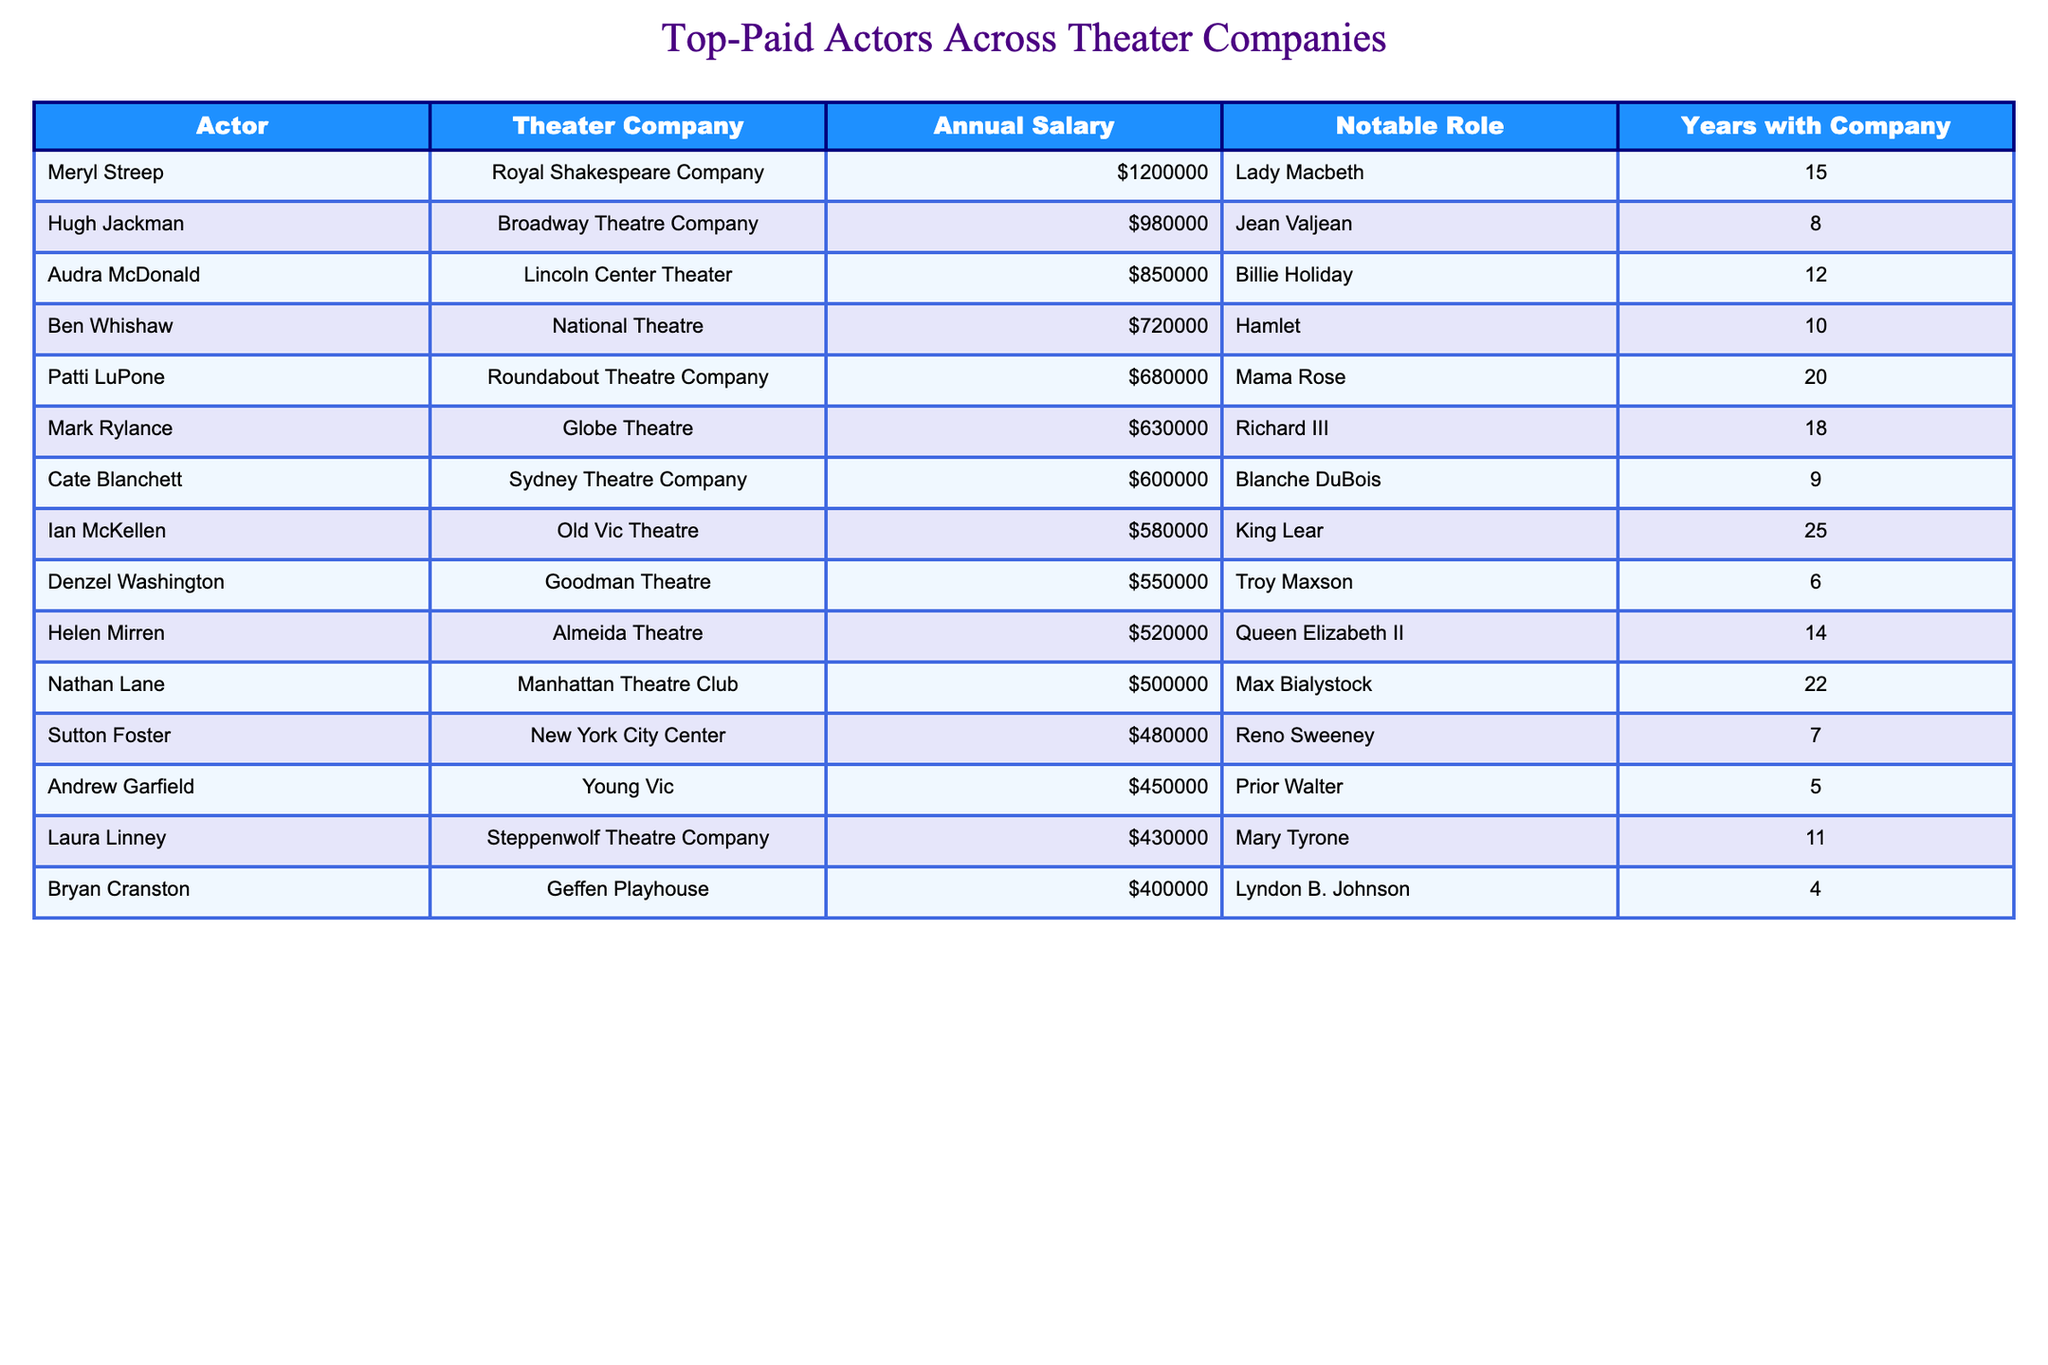What is the highest annual salary among the actors listed? Meryl Streep has the highest salary of $1,200,000. This is evident from the table where her salary is notably the largest compared to others.
Answer: $1,200,000 Which actor has been with their theater company for the longest time? Ian McKellen has been with the Old Vic Theatre for 25 years, which is the longest tenure noted in the table.
Answer: Ian McKellen What is the combined annual salary of Audra McDonald and Nathan Lane? Audra McDonald earns $850,000 and Nathan Lane earns $500,000. Adding these gives $850,000 + $500,000 = $1,350,000.
Answer: $1,350,000 Is Denzel Washington's salary more than that of Cate Blanchett? No, Denzel Washington's salary is $550,000, while Cate Blanchett's salary is $600,000, making her salary higher.
Answer: No What is the average annual salary of the actors listed? To find the average, sum all the salaries: $1,200,000 + $980,000 + $850,000 + $720,000 + $680,000 + $630,000 + $600,000 + $580,000 + $550,000 + $520,000 + $500,000 + $480,000 + $450,000 + $430,000 + $400,000 = $10,500,000. There are 15 actors, so the average is $10,500,000 / 15 = $700,000.
Answer: $700,000 Which theater company pays more on average, Royal Shakespeare Company or Roundabout Theatre Company? The annual salary for Royal Shakespeare Company is $1,200,000, and for Roundabout Theatre Company, it is $680,000. Since only one actor is in each, Royal Shakespeare Company pays more.
Answer: Royal Shakespeare Company How many actors earn a salary of $500,000 or more? The table lists 10 actors whose salaries are $500,000 or more. By counting them directly from the rows, you can see which salaries meet this criterion.
Answer: 10 If you compare the salaries of Meryl Streep and Hugh Jackman, how much more does Meryl Streep earn? Meryl Streep earns $1,200,000, while Hugh Jackman earns $980,000. The difference is calculated as $1,200,000 - $980,000 = $220,000.
Answer: $220,000 Is Laura Linney's salary closest to $430,000 or $460,000? Laura Linney earns exactly $430,000. Since there is no salary listed that is $460,000, her salary is closest to $430,000, matching it exactly.
Answer: $430,000 Which actor's notable role is King Lear and how long have they been with their company? Ian McKellen played King Lear and he has been with the Old Vic Theatre for 25 years, as per the information from the table.
Answer: Ian McKellen, 25 years What is the salary difference between the top earner and the lowest earner? The highest earner, Meryl Streep, earns $1,200,000, and the lowest earner, Bryan Cranston, earns $400,000. The difference is $1,200,000 - $400,000 = $800,000.
Answer: $800,000 